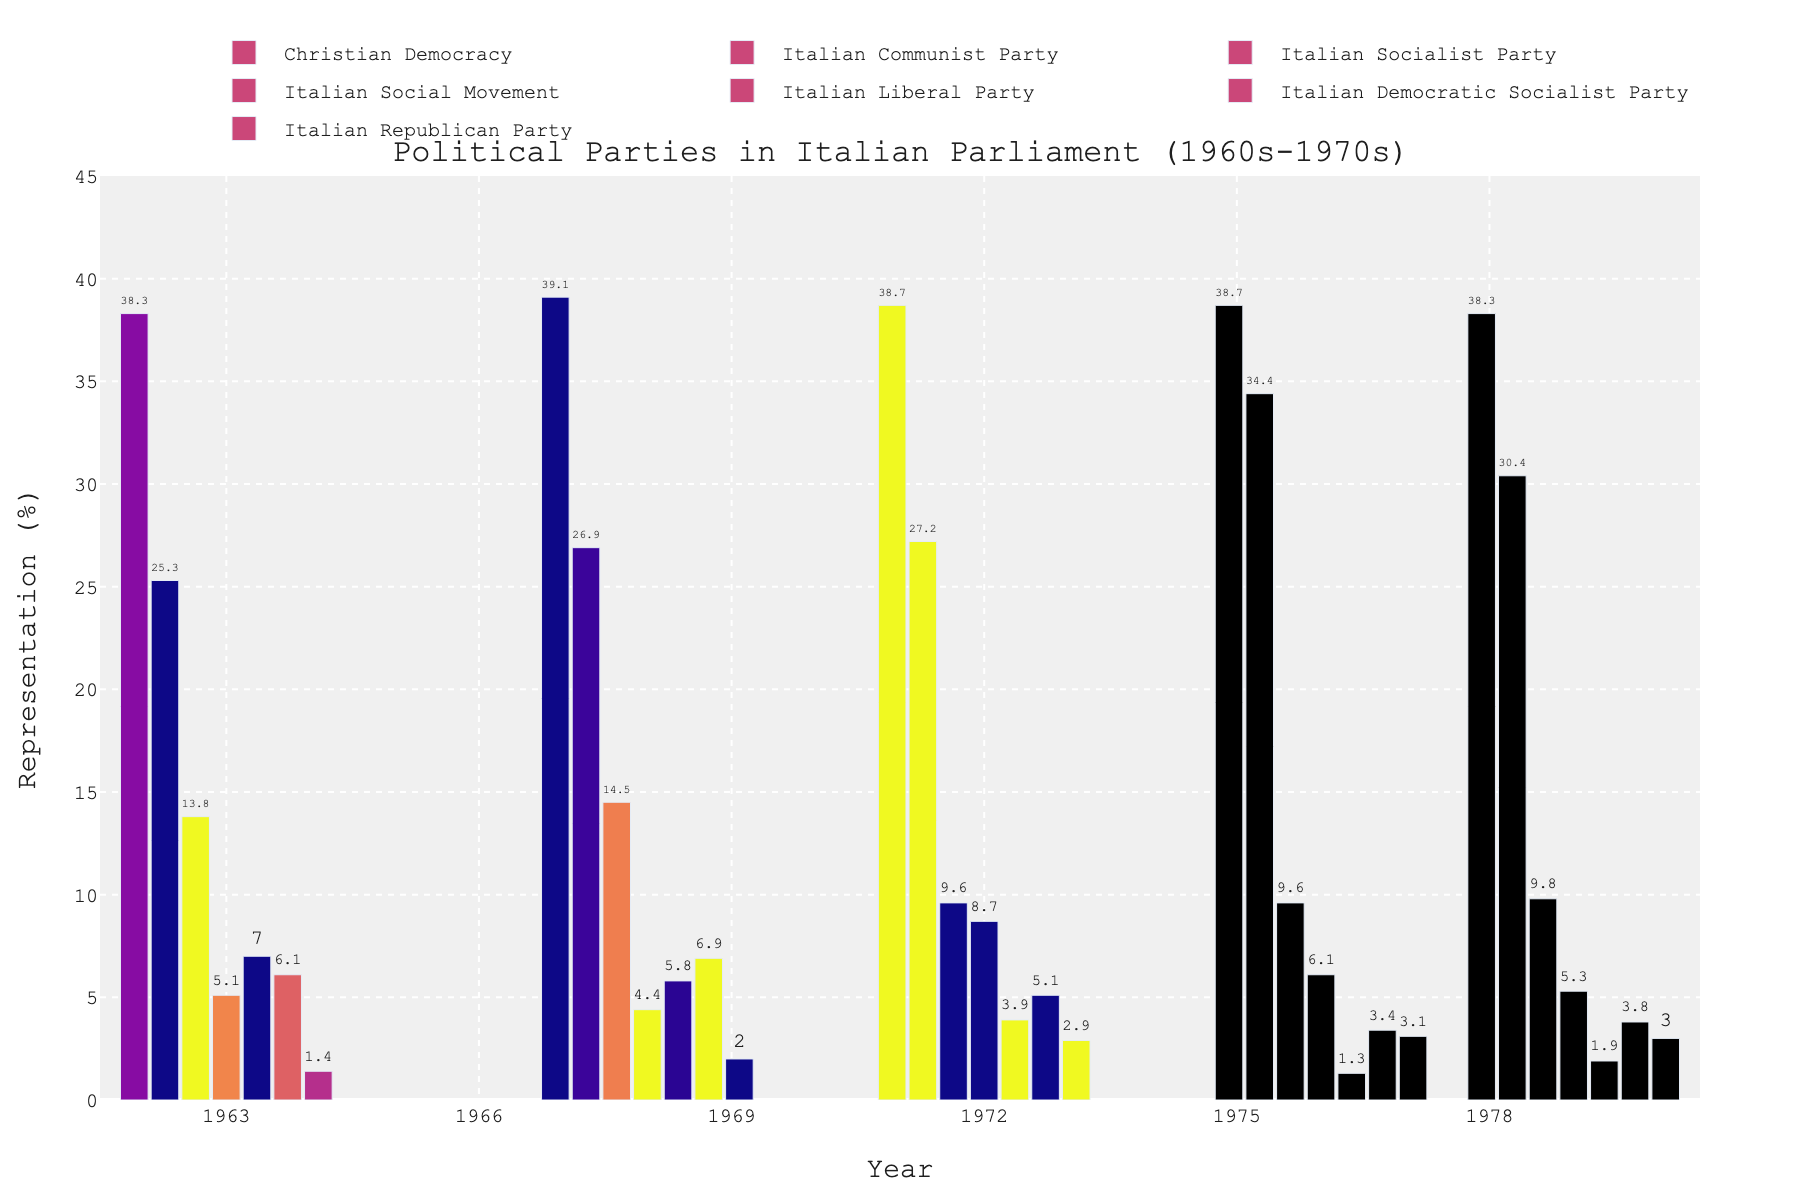Which political party had the highest representation in the Italian Parliament in 1979? By looking at the bar heights for 1979, the bar for Christian Democracy is the tallest.
Answer: Christian Democracy Which two parties had the greatest increase in percentage points from 1963 to 1976? To find the greatest increases, we need to compare the percentages for each party from 1963 and 1976. The Italian Communist Party increased from 25.3% to 34.4% (a 9.1-point increase), and the Italian Republican Party increased from 1.4% to 3.1% (a 1.7-point increase).
Answer: Italian Communist Party and Italian Republican Party What was the combined representation of the Italian Socialist Party and the Italian Social Movement in 1968? The representation of the Italian Socialist Party in 1968 was 14.5%, and the Italian Social Movement was 4.4%. Adding these together, we get 14.5% + 4.4% = 18.9%.
Answer: 18.9% Which party showed the most consistent representation over the years 1963 to 1979? Looking at the bar heights across all years, Christian Democracy's bar heights show minimal fluctuation around 38-39%. This indicates that their representation remained the most consistent.
Answer: Christian Democracy How did the representation of the Italian Liberal Party change between 1963 and 1979? In 1963, the Italian Liberal Party had a representation of 7.0%. In 1979, it was 1.9%. The change is 7.0% - 1.9% = a decrease of 5.1 percentage points.
Answer: Decreased by 5.1 percentage points In which year did the Italian Communist Party have the highest representation? By comparing the bar heights for the Italian Communist Party across all years, the highest bar is in 1976.
Answer: 1976 Compare the representation of the Italian Socialist Party in 1963 and 1972. Was it greater or smaller in 1963? In 1963, the Italian Socialist Party had a representation of 13.8%, while in 1972, it was 9.6%. Therefore, it was greater in 1963.
Answer: Greater in 1963 What is the average representation of the Italian Democratic Socialist Party across all the years shown? The Italian Democratic Socialist Party's representation from 1963 to 1979 is 6.1%, 6.9%, 5.1%, 3.4%, and 3.8%. Adding these together gives 25.3%. Dividing by 5, the average is 25.3% / 5 = 5.06%.
Answer: 5.06% 